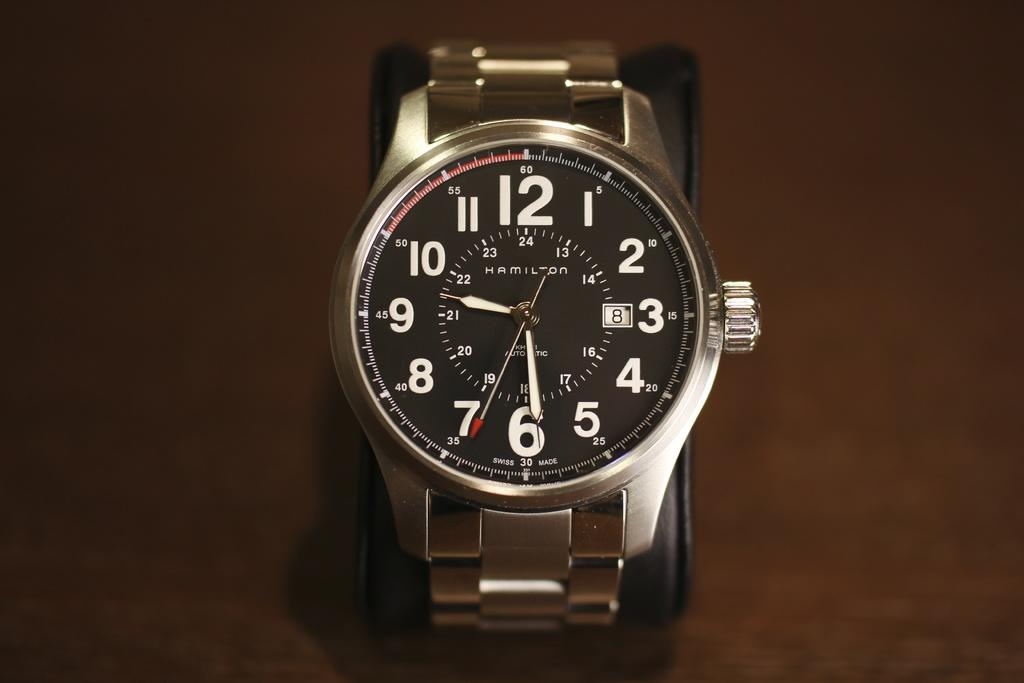Provide a one-sentence caption for the provided image. Hamilton automatic silver watch with numbers for the time. 